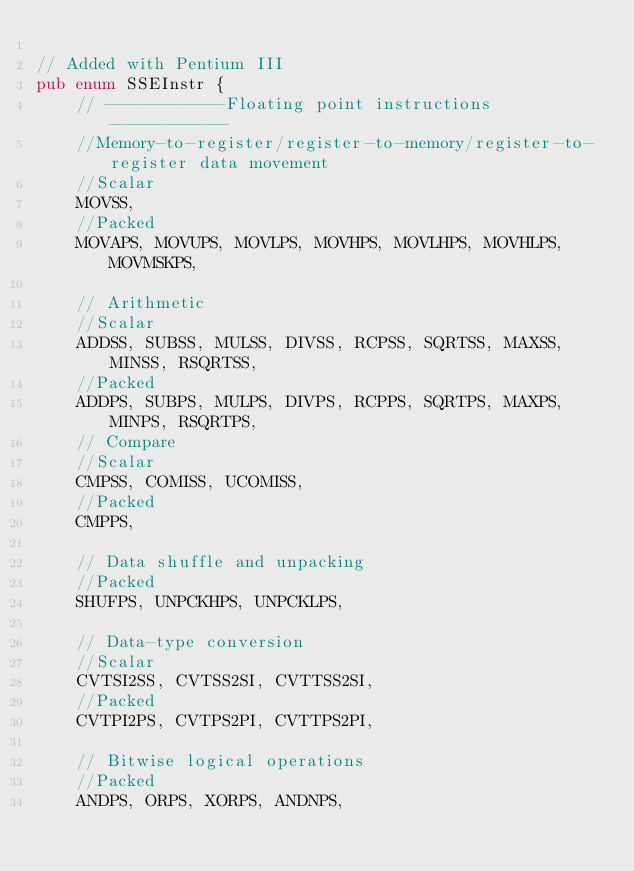Convert code to text. <code><loc_0><loc_0><loc_500><loc_500><_Rust_>
// Added with Pentium III
pub enum SSEInstr {
    // ------------Floating point instructions------------
    //Memory-to-register/register-to-memory/register-to-register data movement
    //Scalar
    MOVSS,
    //Packed
    MOVAPS, MOVUPS, MOVLPS, MOVHPS, MOVLHPS, MOVHLPS, MOVMSKPS,

    // Arithmetic
    //Scalar
    ADDSS, SUBSS, MULSS, DIVSS, RCPSS, SQRTSS, MAXSS, MINSS, RSQRTSS,
    //Packed
    ADDPS, SUBPS, MULPS, DIVPS, RCPPS, SQRTPS, MAXPS, MINPS, RSQRTPS,
    // Compare
    //Scalar
    CMPSS, COMISS, UCOMISS,
    //Packed
    CMPPS,

    // Data shuffle and unpacking
    //Packed
    SHUFPS, UNPCKHPS, UNPCKLPS,

    // Data-type conversion
    //Scalar
    CVTSI2SS, CVTSS2SI, CVTTSS2SI,
    //Packed
    CVTPI2PS, CVTPS2PI, CVTTPS2PI,

    // Bitwise logical operations
    //Packed
    ANDPS, ORPS, XORPS, ANDNPS,
</code> 